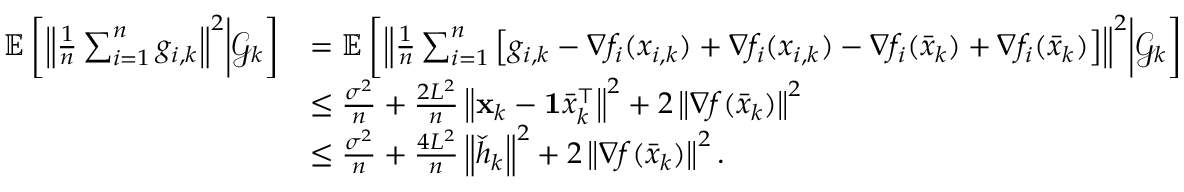<formula> <loc_0><loc_0><loc_500><loc_500>\begin{array} { r l } { \mathbb { E } \left [ \left \| \frac { 1 } { n } \sum _ { i = 1 } ^ { n } g _ { i , k } \right \| ^ { 2 } | d l e | \mathcal { G } _ { k } \right ] } & { = \mathbb { E } \left [ \left \| \frac { 1 } { n } \sum _ { i = 1 } ^ { n } \left [ g _ { i , k } - \nabla f _ { i } ( x _ { i , k } ) + \nabla f _ { i } ( x _ { i , k } ) - \nabla f _ { i } ( \bar { x } _ { k } ) + \nabla f _ { i } ( \bar { x } _ { k } ) \right ] \right \| ^ { 2 } | d l e | \mathcal { G } _ { k } \right ] } \\ & { \leq \frac { \sigma ^ { 2 } } { n } + \frac { 2 L ^ { 2 } } { n } \left \| x _ { k } - 1 \bar { x } _ { k } ^ { \intercal } \right \| ^ { 2 } + 2 \left \| \nabla f ( \bar { x } _ { k } ) \right \| ^ { 2 } } \\ & { \leq \frac { \sigma ^ { 2 } } { n } + \frac { 4 L ^ { 2 } } { n } \left \| \check { h } _ { k } \right \| ^ { 2 } + 2 \left \| \nabla f ( \bar { x } _ { k } ) \right \| ^ { 2 } . } \end{array}</formula> 